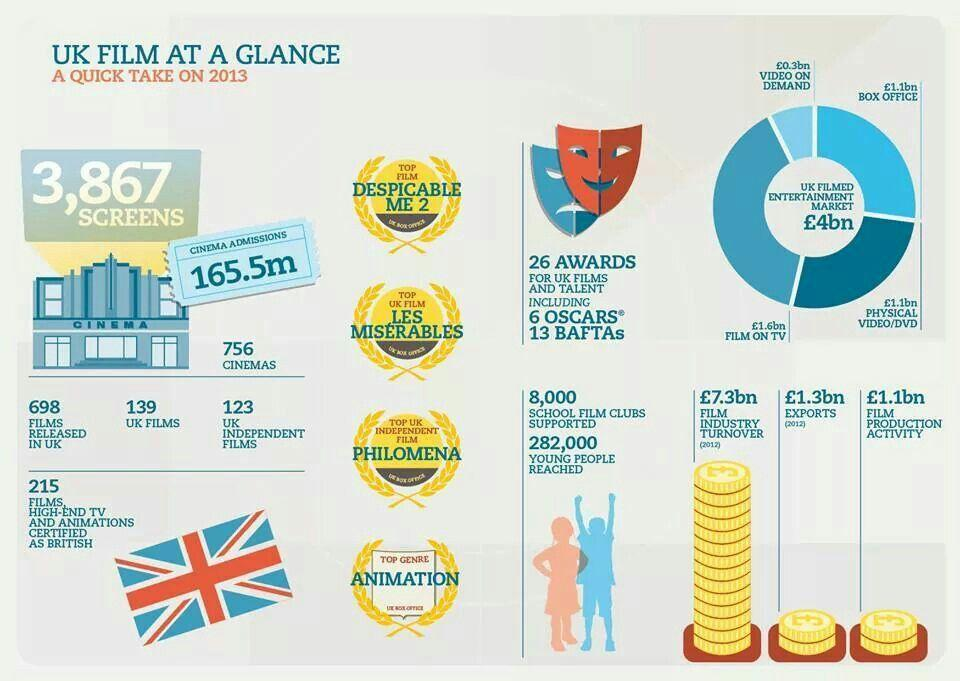What is the amount for Film on TV in the UK filmed Entertainment market?
Answer the question with a short phrase. £1.6bn What is the amount for Exports? £1.3bn What is the amount for Box Office in the UK filmed Entertainment market? £1.1bn How much is the Film industry turnover? £7.3bn How many School film clubs are supported? 8,000 What is the total number of films released in UK? 698 What is the amount for video on demand in the UK filmed Entertainment market? £0.3bn What is the amount for film production activity? £1.1bn 